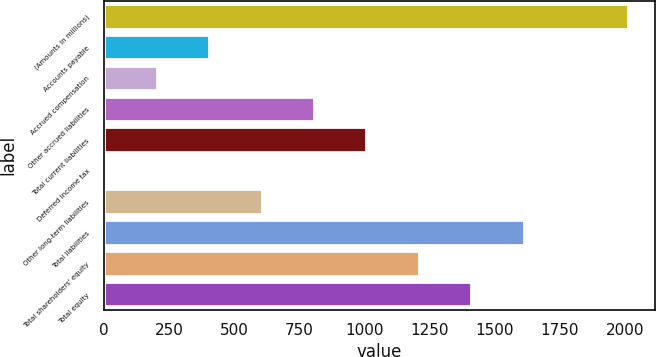Convert chart. <chart><loc_0><loc_0><loc_500><loc_500><bar_chart><fcel>(Amounts in millions)<fcel>Accounts payable<fcel>Accrued compensation<fcel>Other accrued liabilities<fcel>Total current liabilities<fcel>Deferred income tax<fcel>Other long-term liabilities<fcel>Total liabilities<fcel>Total shareholders' equity<fcel>Total equity<nl><fcel>2013<fcel>403.48<fcel>202.29<fcel>805.86<fcel>1007.05<fcel>1.1<fcel>604.67<fcel>1610.62<fcel>1208.24<fcel>1409.43<nl></chart> 